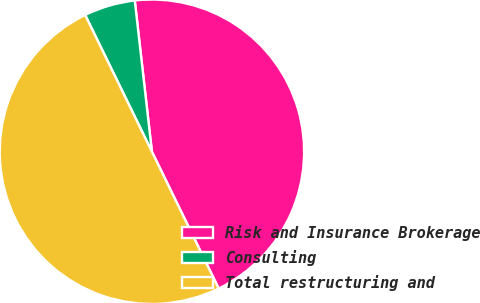<chart> <loc_0><loc_0><loc_500><loc_500><pie_chart><fcel>Risk and Insurance Brokerage<fcel>Consulting<fcel>Total restructuring and<nl><fcel>44.57%<fcel>5.43%<fcel>50.0%<nl></chart> 